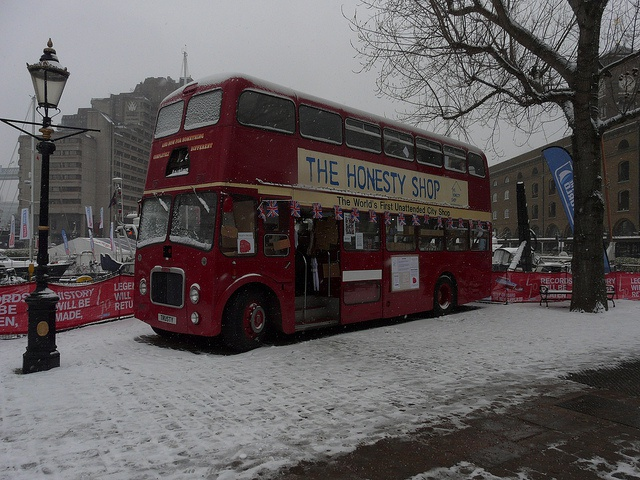Describe the objects in this image and their specific colors. I can see bus in darkgray, black, gray, and maroon tones, boat in darkgray, black, and gray tones, and bench in darkgray, black, and gray tones in this image. 